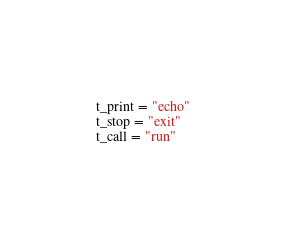<code> <loc_0><loc_0><loc_500><loc_500><_Python_>t_print = "echo"
t_stop = "exit"
t_call = "run"</code> 